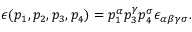<formula> <loc_0><loc_0><loc_500><loc_500>\epsilon ( p _ { 1 } , p _ { 2 } , p _ { 3 } , p _ { 4 } ) = p _ { 1 } ^ { \alpha } p _ { 3 } ^ { \gamma } p _ { 4 } ^ { \sigma } \epsilon _ { \alpha \beta \gamma \sigma } .</formula> 